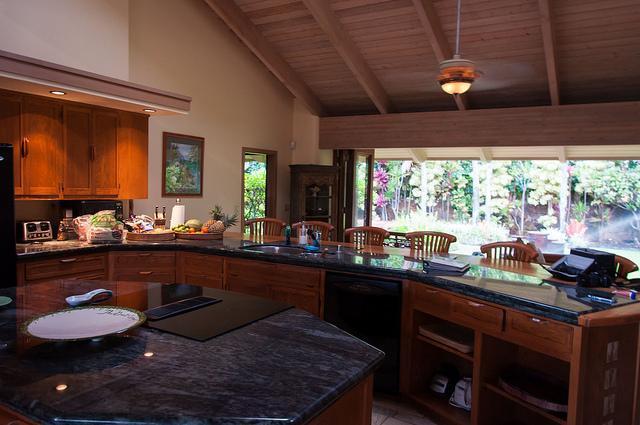How many stools are under the table?
Give a very brief answer. 6. How many windows are there?
Give a very brief answer. 1. How many lamps are turned off?
Give a very brief answer. 0. How many pictures are hanging?
Give a very brief answer. 1. How many umbrellas are in the picture?
Give a very brief answer. 0. 